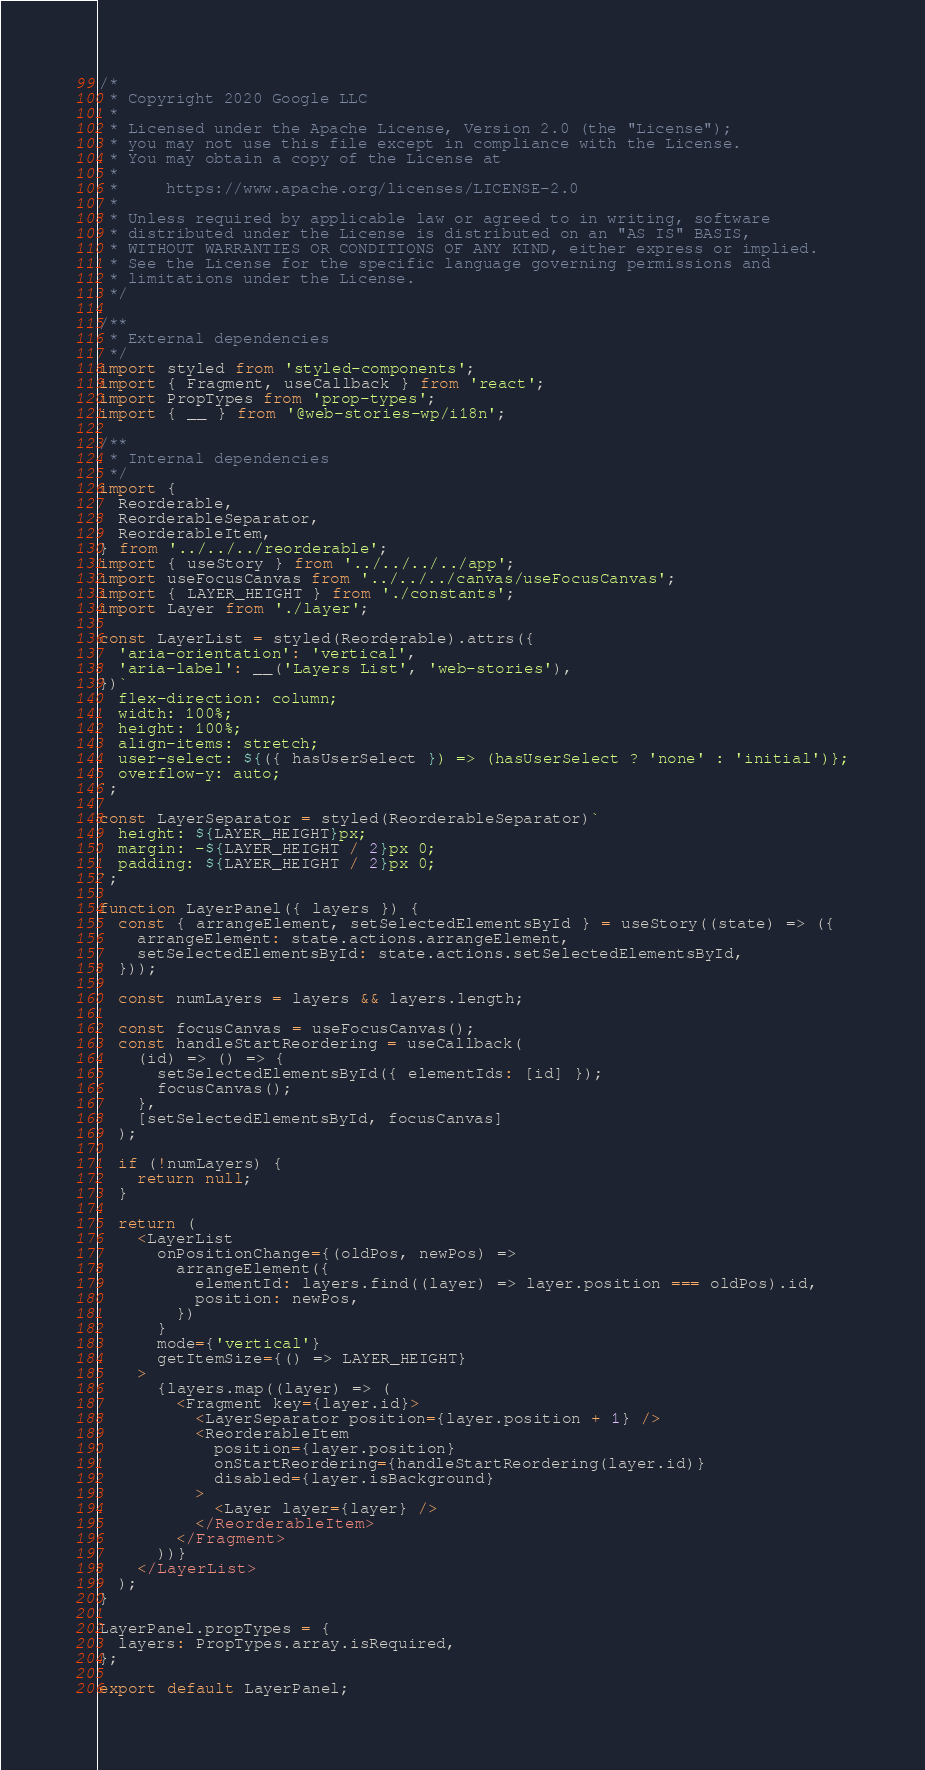Convert code to text. <code><loc_0><loc_0><loc_500><loc_500><_JavaScript_>/*
 * Copyright 2020 Google LLC
 *
 * Licensed under the Apache License, Version 2.0 (the "License");
 * you may not use this file except in compliance with the License.
 * You may obtain a copy of the License at
 *
 *     https://www.apache.org/licenses/LICENSE-2.0
 *
 * Unless required by applicable law or agreed to in writing, software
 * distributed under the License is distributed on an "AS IS" BASIS,
 * WITHOUT WARRANTIES OR CONDITIONS OF ANY KIND, either express or implied.
 * See the License for the specific language governing permissions and
 * limitations under the License.
 */

/**
 * External dependencies
 */
import styled from 'styled-components';
import { Fragment, useCallback } from 'react';
import PropTypes from 'prop-types';
import { __ } from '@web-stories-wp/i18n';

/**
 * Internal dependencies
 */
import {
  Reorderable,
  ReorderableSeparator,
  ReorderableItem,
} from '../../../reorderable';
import { useStory } from '../../../../app';
import useFocusCanvas from '../../../canvas/useFocusCanvas';
import { LAYER_HEIGHT } from './constants';
import Layer from './layer';

const LayerList = styled(Reorderable).attrs({
  'aria-orientation': 'vertical',
  'aria-label': __('Layers List', 'web-stories'),
})`
  flex-direction: column;
  width: 100%;
  height: 100%;
  align-items: stretch;
  user-select: ${({ hasUserSelect }) => (hasUserSelect ? 'none' : 'initial')};
  overflow-y: auto;
`;

const LayerSeparator = styled(ReorderableSeparator)`
  height: ${LAYER_HEIGHT}px;
  margin: -${LAYER_HEIGHT / 2}px 0;
  padding: ${LAYER_HEIGHT / 2}px 0;
`;

function LayerPanel({ layers }) {
  const { arrangeElement, setSelectedElementsById } = useStory((state) => ({
    arrangeElement: state.actions.arrangeElement,
    setSelectedElementsById: state.actions.setSelectedElementsById,
  }));

  const numLayers = layers && layers.length;

  const focusCanvas = useFocusCanvas();
  const handleStartReordering = useCallback(
    (id) => () => {
      setSelectedElementsById({ elementIds: [id] });
      focusCanvas();
    },
    [setSelectedElementsById, focusCanvas]
  );

  if (!numLayers) {
    return null;
  }

  return (
    <LayerList
      onPositionChange={(oldPos, newPos) =>
        arrangeElement({
          elementId: layers.find((layer) => layer.position === oldPos).id,
          position: newPos,
        })
      }
      mode={'vertical'}
      getItemSize={() => LAYER_HEIGHT}
    >
      {layers.map((layer) => (
        <Fragment key={layer.id}>
          <LayerSeparator position={layer.position + 1} />
          <ReorderableItem
            position={layer.position}
            onStartReordering={handleStartReordering(layer.id)}
            disabled={layer.isBackground}
          >
            <Layer layer={layer} />
          </ReorderableItem>
        </Fragment>
      ))}
    </LayerList>
  );
}

LayerPanel.propTypes = {
  layers: PropTypes.array.isRequired,
};

export default LayerPanel;
</code> 